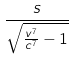<formula> <loc_0><loc_0><loc_500><loc_500>\frac { s } { \sqrt { \frac { v ^ { 7 } } { c ^ { 7 } } - 1 } }</formula> 